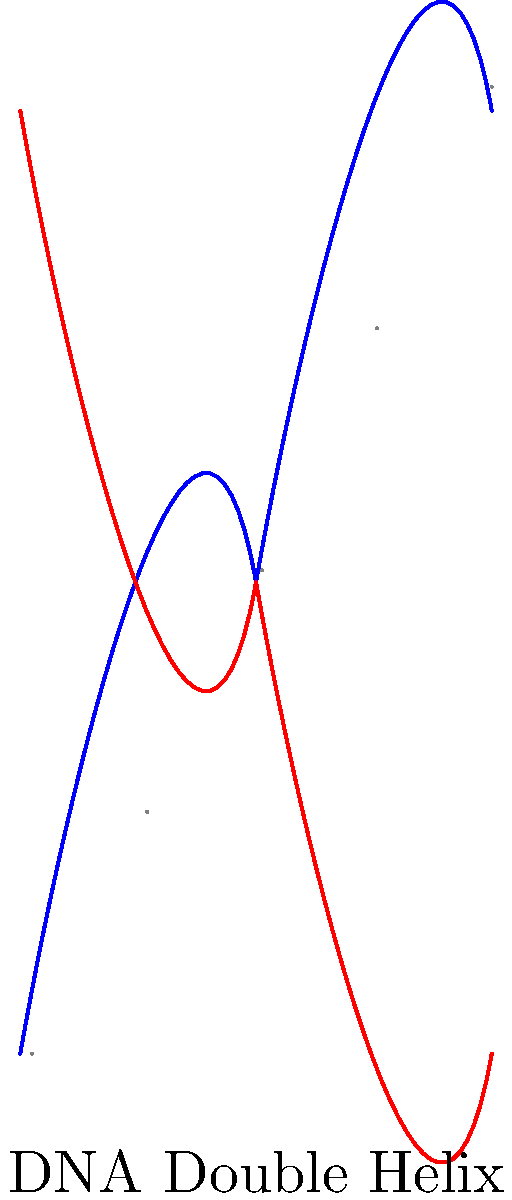Analyze the ethical implications of using DNA-based evidence in criminal investigations. Consider the potential for both enhanced justice and privacy violations. How might the use of familial DNA searches impact marginalized communities disproportionately? Provide a balanced argument addressing both the benefits and risks of this technology in criminology. 1. Benefits of DNA-based evidence:
   a) Increased accuracy in identifying suspects
   b) Potential to exonerate wrongfully convicted individuals
   c) Deterrent effect on potential criminals

2. Privacy concerns:
   a) Risk of genetic information misuse
   b) Potential for unauthorized access to DNA databases
   c) Violation of genetic privacy rights of individuals not directly involved in investigations

3. Familial DNA searches:
   a) Definition: Using DNA databases to identify relatives of potential suspects
   b) Ethical concerns:
      - Disproportionate impact on communities with higher rates of incarceration
      - Potential racial bias in DNA database representation

4. Impact on marginalized communities:
   a) Overrepresentation in criminal justice system leading to higher likelihood of DNA collection
   b) Increased surveillance and potential for false positives
   c) Exacerbation of existing systemic biases

5. Balancing benefits and risks:
   a) Implementing strict regulations on DNA collection and storage
   b) Ensuring transparency in the use of DNA evidence
   c) Developing ethical guidelines for familial DNA searches
   d) Regular audits of DNA databases and their usage

6. Future considerations:
   a) Advancements in DNA technology and their potential impact on privacy
   b) Need for ongoing ethical review and policy updates
   c) Importance of public education and informed consent in DNA collection

The ethical use of DNA-based evidence in criminal investigations requires a careful balance between enhancing justice and protecting individual privacy rights, with particular attention to the potential disproportionate impact on marginalized communities.
Answer: Balanced approach: Implement strict regulations, ensure transparency, develop ethical guidelines, and conduct regular audits to maximize benefits of DNA evidence while minimizing privacy violations and disproportionate impacts on marginalized communities. 